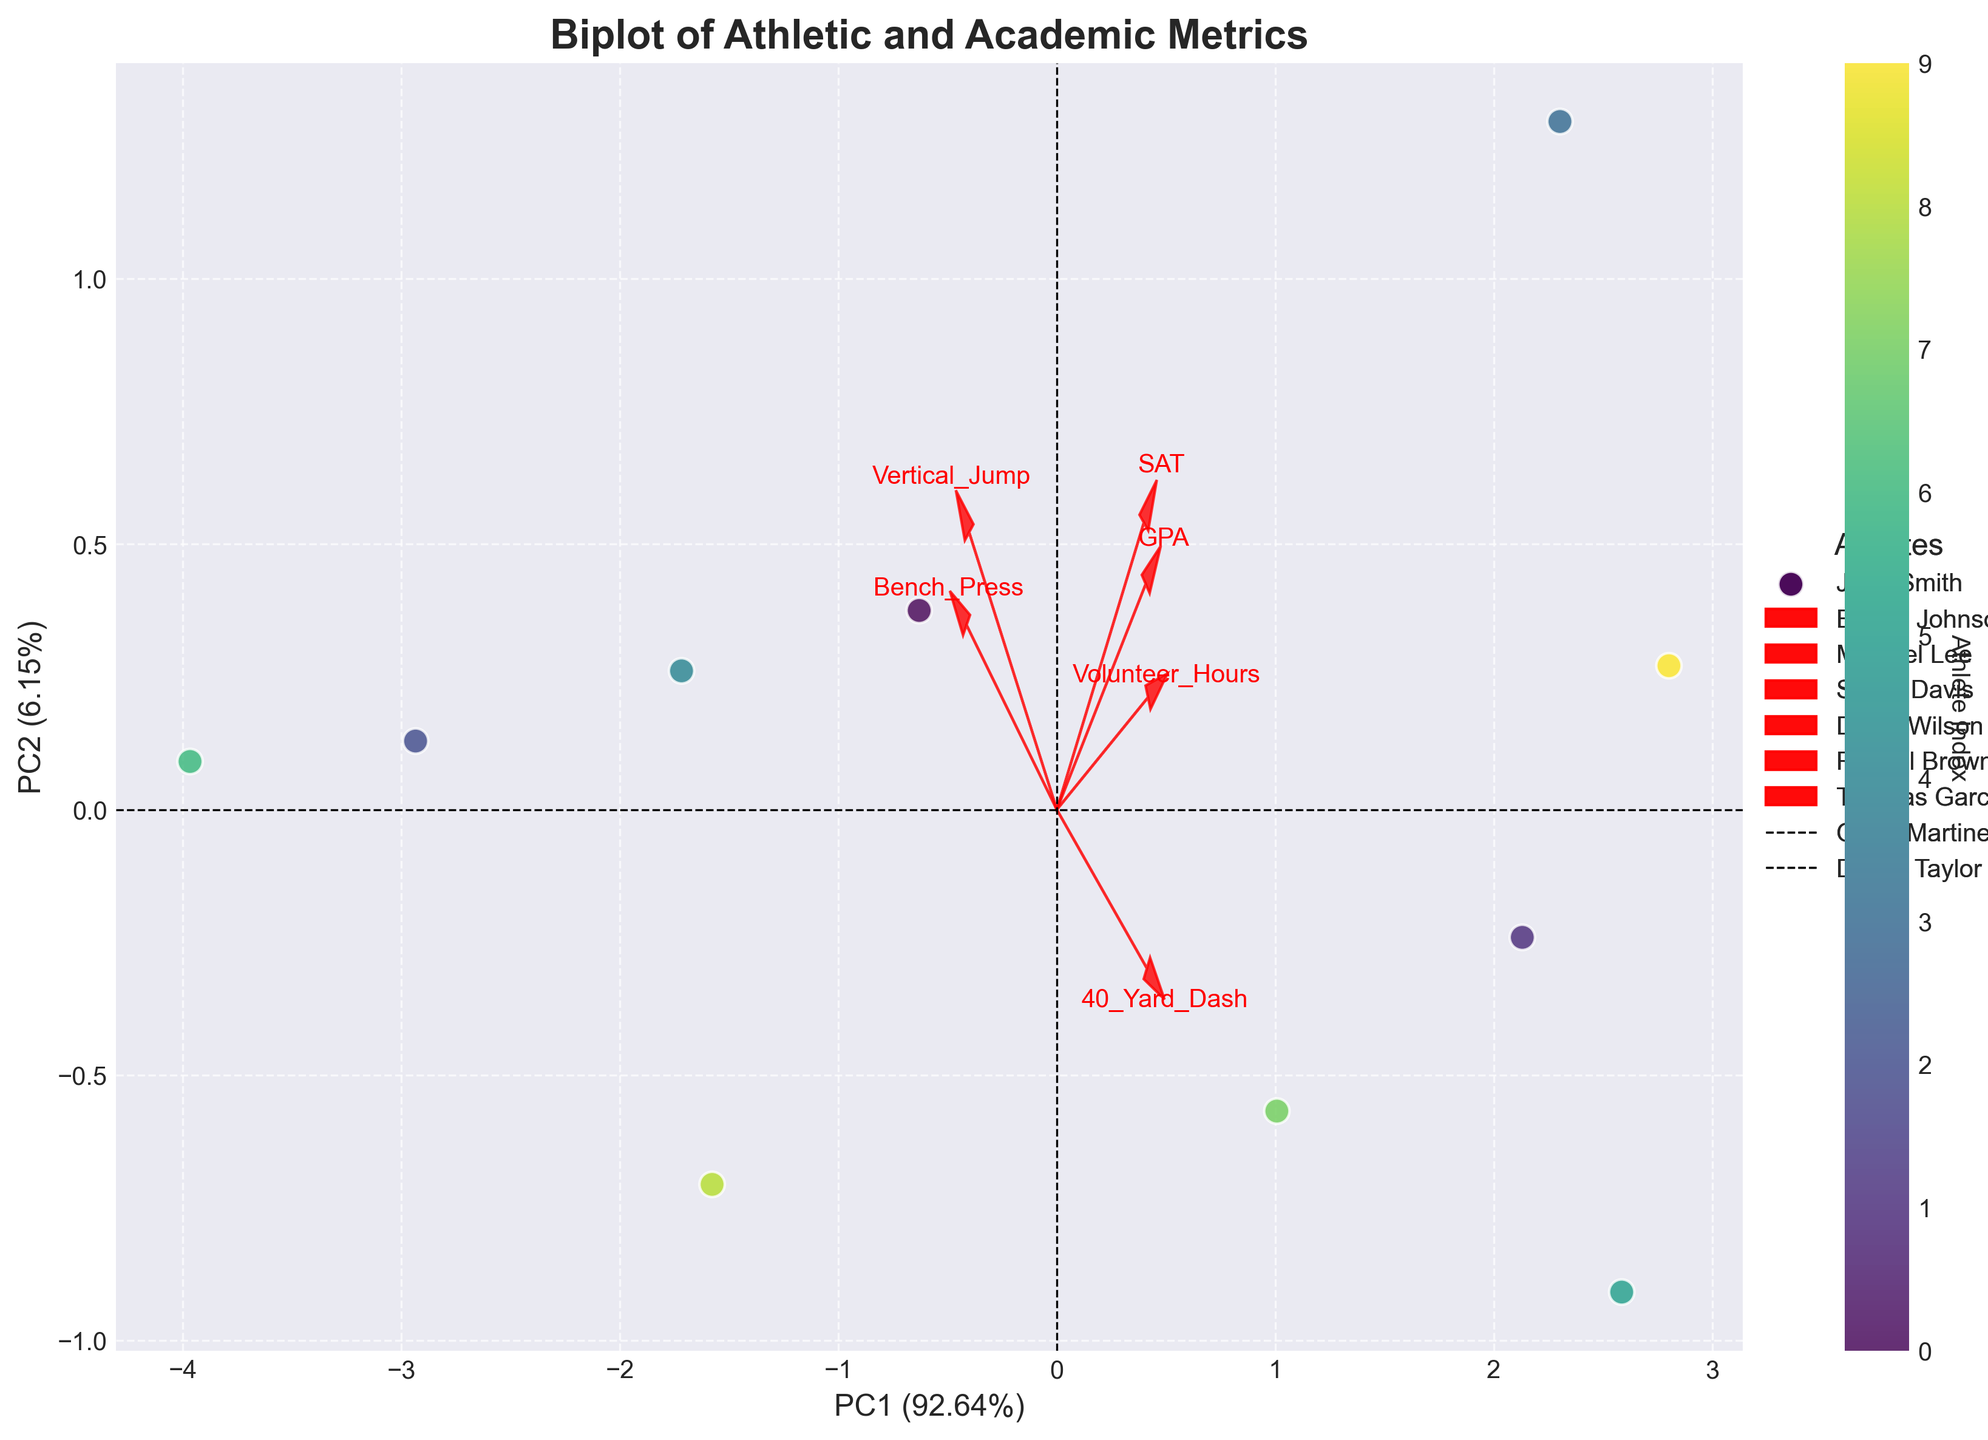What's the title of the figure? The figure has a specific title displayed at the top, which summarizes the content of the plot.
Answer: Biplot of Athletic and Academic Metrics How many athletes are represented in the plot? The number of athletes can be counted by observing the distinct data points within the scatter plot.
Answer: 10 Which two athletes have the highest and lowest scores on PC1, respectively? Observe the data points on the x-axis (PC1) for their positioning; the farthest right has the highest score, and the farthest left has the lowest score.
Answer: Michael Lee (highest), Rachel Brown (lowest) Which variable is most strongly aligned with PC1? The variable that is most aligned with the PC1 axis will have its arrow pointing closest to the horizontal direction.
Answer: Bench_Press Which athlete has the highest Volunteer Hours, and how can you tell? Look for the athlete data point closest to the arrow pointing toward the variable "Volunteer_Hours," indicating alignment.
Answer: Sarah Davis Which variables are positively correlated with GPA based on their direction in the plot? Variables with arrows pointing in a similar direction as the GPA arrow are positively correlated.
Answer: SAT, Volunteer_Hours How do Bench_Press and Vertical_Jump relate to each other in the biplot? The relationship can be inferred from the angles of their arrows. If they point in similar directions, they are positively correlated; if they are opposite, they are negatively correlated.
Answer: Moderately positively correlated Which primary component explains more variance, PC1 or PC2? The variance explained by each principal component is typically noted in percentage terms on the axis. The higher percentage denotes the component explaining more variance.
Answer: PC1 What is the range of explained variance by PC1 and PC2 combined? Combine the individual percentages reported for PC1 and PC2.
Answer: Summation of the explained variance percentages for PC1 and PC2 (e.g., PC1: 57%, PC2: 20%, combined is 77%) Which athlete is closest to the origin of the biplot, and what might this imply? The closest point to the origin (0,0) can be found by observing the scatter plot. This implies the athlete's metrics are near-average across all variables standardized.
Answer: Daniel Taylor 